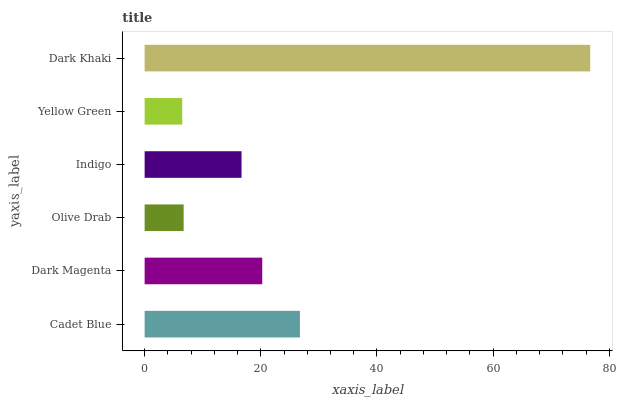Is Yellow Green the minimum?
Answer yes or no. Yes. Is Dark Khaki the maximum?
Answer yes or no. Yes. Is Dark Magenta the minimum?
Answer yes or no. No. Is Dark Magenta the maximum?
Answer yes or no. No. Is Cadet Blue greater than Dark Magenta?
Answer yes or no. Yes. Is Dark Magenta less than Cadet Blue?
Answer yes or no. Yes. Is Dark Magenta greater than Cadet Blue?
Answer yes or no. No. Is Cadet Blue less than Dark Magenta?
Answer yes or no. No. Is Dark Magenta the high median?
Answer yes or no. Yes. Is Indigo the low median?
Answer yes or no. Yes. Is Indigo the high median?
Answer yes or no. No. Is Yellow Green the low median?
Answer yes or no. No. 